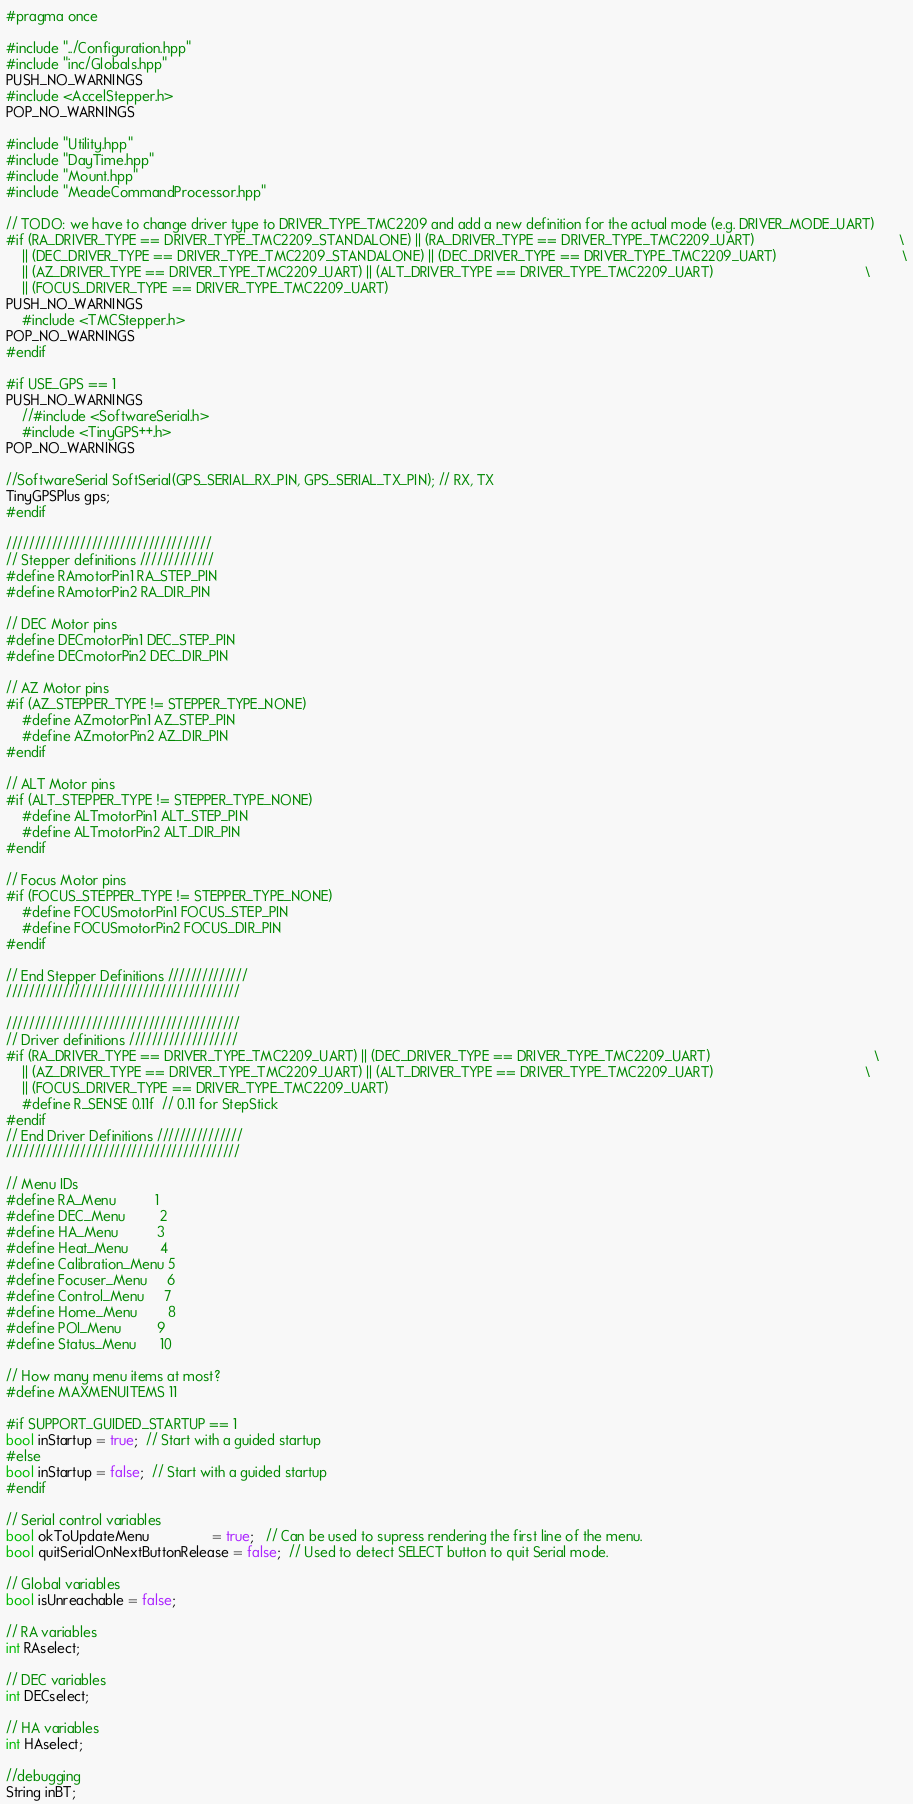<code> <loc_0><loc_0><loc_500><loc_500><_C++_>#pragma once

#include "../Configuration.hpp"
#include "inc/Globals.hpp"
PUSH_NO_WARNINGS
#include <AccelStepper.h>
POP_NO_WARNINGS

#include "Utility.hpp"
#include "DayTime.hpp"
#include "Mount.hpp"
#include "MeadeCommandProcessor.hpp"

// TODO: we have to change driver type to DRIVER_TYPE_TMC2209 and add a new definition for the actual mode (e.g. DRIVER_MODE_UART)
#if (RA_DRIVER_TYPE == DRIVER_TYPE_TMC2209_STANDALONE) || (RA_DRIVER_TYPE == DRIVER_TYPE_TMC2209_UART)                                     \
    || (DEC_DRIVER_TYPE == DRIVER_TYPE_TMC2209_STANDALONE) || (DEC_DRIVER_TYPE == DRIVER_TYPE_TMC2209_UART)                                \
    || (AZ_DRIVER_TYPE == DRIVER_TYPE_TMC2209_UART) || (ALT_DRIVER_TYPE == DRIVER_TYPE_TMC2209_UART)                                       \
    || (FOCUS_DRIVER_TYPE == DRIVER_TYPE_TMC2209_UART)
PUSH_NO_WARNINGS
    #include <TMCStepper.h>
POP_NO_WARNINGS
#endif

#if USE_GPS == 1
PUSH_NO_WARNINGS
    //#include <SoftwareSerial.h>
    #include <TinyGPS++.h>
POP_NO_WARNINGS

//SoftwareSerial SoftSerial(GPS_SERIAL_RX_PIN, GPS_SERIAL_TX_PIN); // RX, TX
TinyGPSPlus gps;
#endif

////////////////////////////////////
// Stepper definitions /////////////
#define RAmotorPin1 RA_STEP_PIN
#define RAmotorPin2 RA_DIR_PIN

// DEC Motor pins
#define DECmotorPin1 DEC_STEP_PIN
#define DECmotorPin2 DEC_DIR_PIN

// AZ Motor pins
#if (AZ_STEPPER_TYPE != STEPPER_TYPE_NONE)
    #define AZmotorPin1 AZ_STEP_PIN
    #define AZmotorPin2 AZ_DIR_PIN
#endif

// ALT Motor pins
#if (ALT_STEPPER_TYPE != STEPPER_TYPE_NONE)
    #define ALTmotorPin1 ALT_STEP_PIN
    #define ALTmotorPin2 ALT_DIR_PIN
#endif

// Focus Motor pins
#if (FOCUS_STEPPER_TYPE != STEPPER_TYPE_NONE)
    #define FOCUSmotorPin1 FOCUS_STEP_PIN
    #define FOCUSmotorPin2 FOCUS_DIR_PIN
#endif

// End Stepper Definitions //////////////
/////////////////////////////////////////

/////////////////////////////////////////
// Driver definitions ///////////////////
#if (RA_DRIVER_TYPE == DRIVER_TYPE_TMC2209_UART) || (DEC_DRIVER_TYPE == DRIVER_TYPE_TMC2209_UART)                                          \
    || (AZ_DRIVER_TYPE == DRIVER_TYPE_TMC2209_UART) || (ALT_DRIVER_TYPE == DRIVER_TYPE_TMC2209_UART)                                       \
    || (FOCUS_DRIVER_TYPE == DRIVER_TYPE_TMC2209_UART)
    #define R_SENSE 0.11f  // 0.11 for StepStick
#endif
// End Driver Definitions ///////////////
/////////////////////////////////////////

// Menu IDs
#define RA_Menu          1
#define DEC_Menu         2
#define HA_Menu          3
#define Heat_Menu        4
#define Calibration_Menu 5
#define Focuser_Menu     6
#define Control_Menu     7
#define Home_Menu        8
#define POI_Menu         9
#define Status_Menu      10

// How many menu items at most?
#define MAXMENUITEMS 11

#if SUPPORT_GUIDED_STARTUP == 1
bool inStartup = true;  // Start with a guided startup
#else
bool inStartup = false;  // Start with a guided startup
#endif

// Serial control variables
bool okToUpdateMenu                = true;   // Can be used to supress rendering the first line of the menu.
bool quitSerialOnNextButtonRelease = false;  // Used to detect SELECT button to quit Serial mode.

// Global variables
bool isUnreachable = false;

// RA variables
int RAselect;

// DEC variables
int DECselect;

// HA variables
int HAselect;

//debugging
String inBT;
</code> 